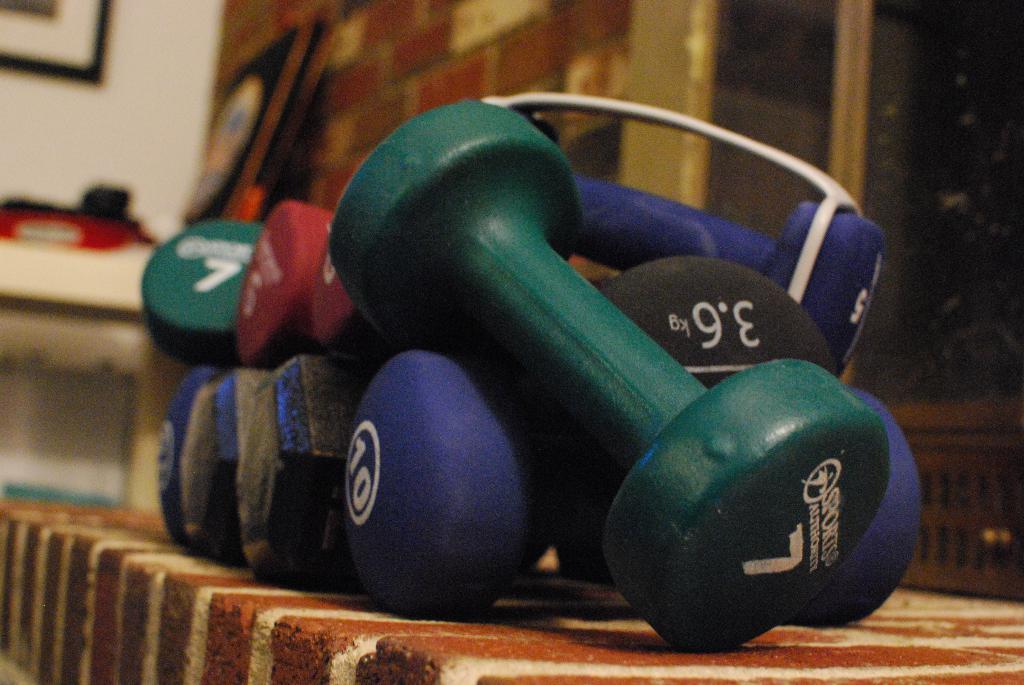Please provide a concise description of this image. In this image there is table, a frame on the wall in the left corner. There are dumbbells in the foreground. There are some frames on wall in the background. And there is a railing in the right corner. 